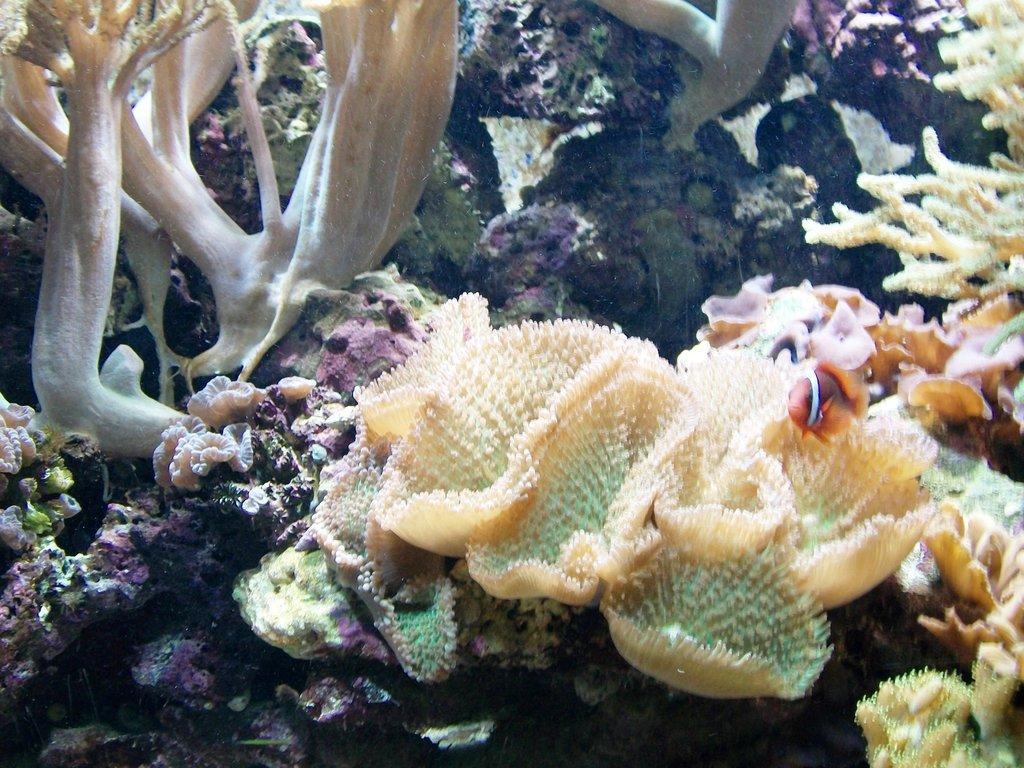Describe this image in one or two sentences. In this image there some corals, marine plants, some fishes and there is water. 